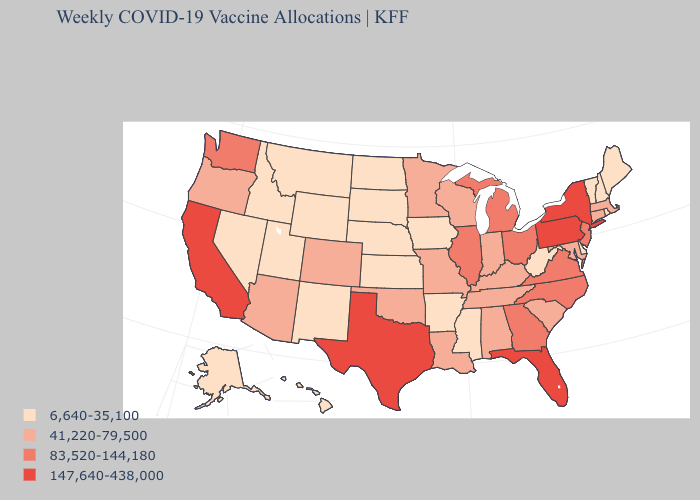Does Colorado have a lower value than Arkansas?
Concise answer only. No. Among the states that border Iowa , which have the lowest value?
Concise answer only. Nebraska, South Dakota. Among the states that border New Hampshire , does Vermont have the highest value?
Write a very short answer. No. What is the value of Hawaii?
Short answer required. 6,640-35,100. Is the legend a continuous bar?
Give a very brief answer. No. Name the states that have a value in the range 147,640-438,000?
Short answer required. California, Florida, New York, Pennsylvania, Texas. Does South Carolina have the highest value in the USA?
Be succinct. No. Does the first symbol in the legend represent the smallest category?
Give a very brief answer. Yes. What is the highest value in the USA?
Give a very brief answer. 147,640-438,000. What is the lowest value in the USA?
Give a very brief answer. 6,640-35,100. Which states have the lowest value in the USA?
Be succinct. Alaska, Arkansas, Delaware, Hawaii, Idaho, Iowa, Kansas, Maine, Mississippi, Montana, Nebraska, Nevada, New Hampshire, New Mexico, North Dakota, Rhode Island, South Dakota, Utah, Vermont, West Virginia, Wyoming. What is the value of Delaware?
Be succinct. 6,640-35,100. Is the legend a continuous bar?
Write a very short answer. No. Does Arizona have the highest value in the USA?
Short answer required. No. 